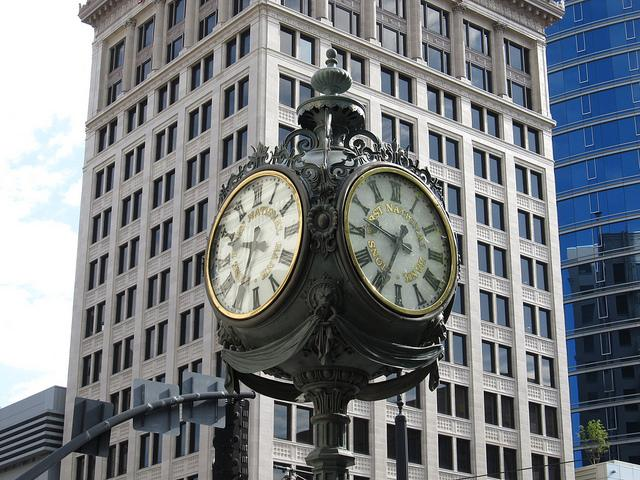What types of buildings are these? Please explain your reasoning. high rise. These are tall buildings in the city. 